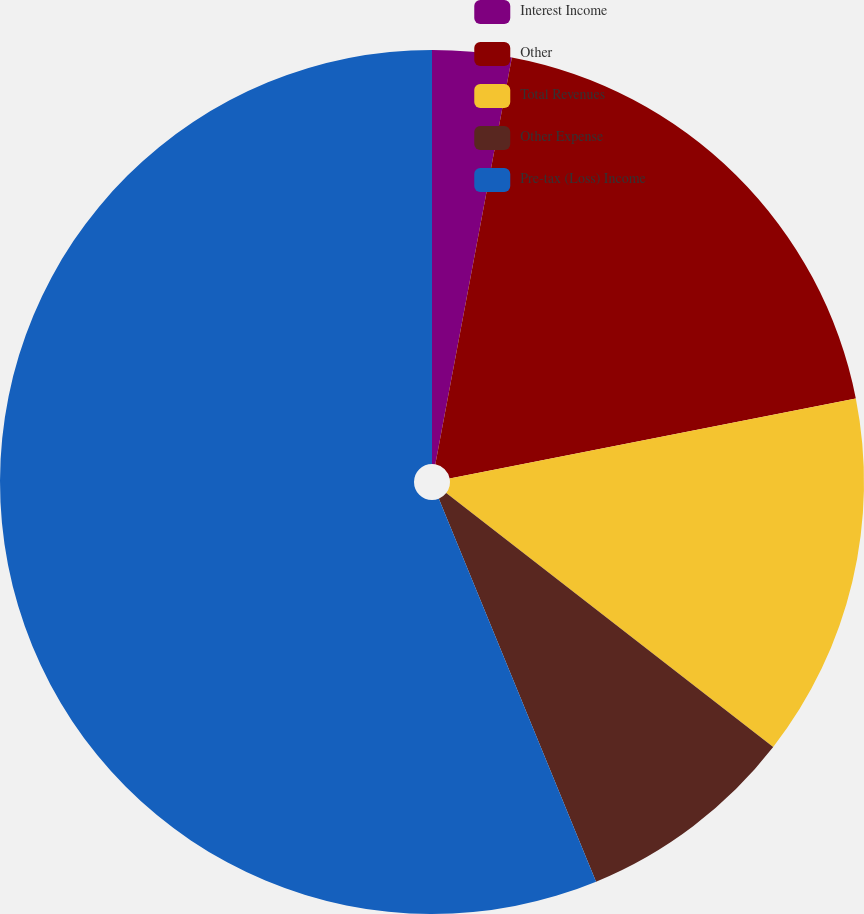<chart> <loc_0><loc_0><loc_500><loc_500><pie_chart><fcel>Interest Income<fcel>Other<fcel>Total Revenues<fcel>Other Expense<fcel>Pre-tax (Loss) Income<nl><fcel>2.96%<fcel>18.94%<fcel>13.61%<fcel>8.29%<fcel>56.2%<nl></chart> 